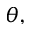Convert formula to latex. <formula><loc_0><loc_0><loc_500><loc_500>\theta ,</formula> 